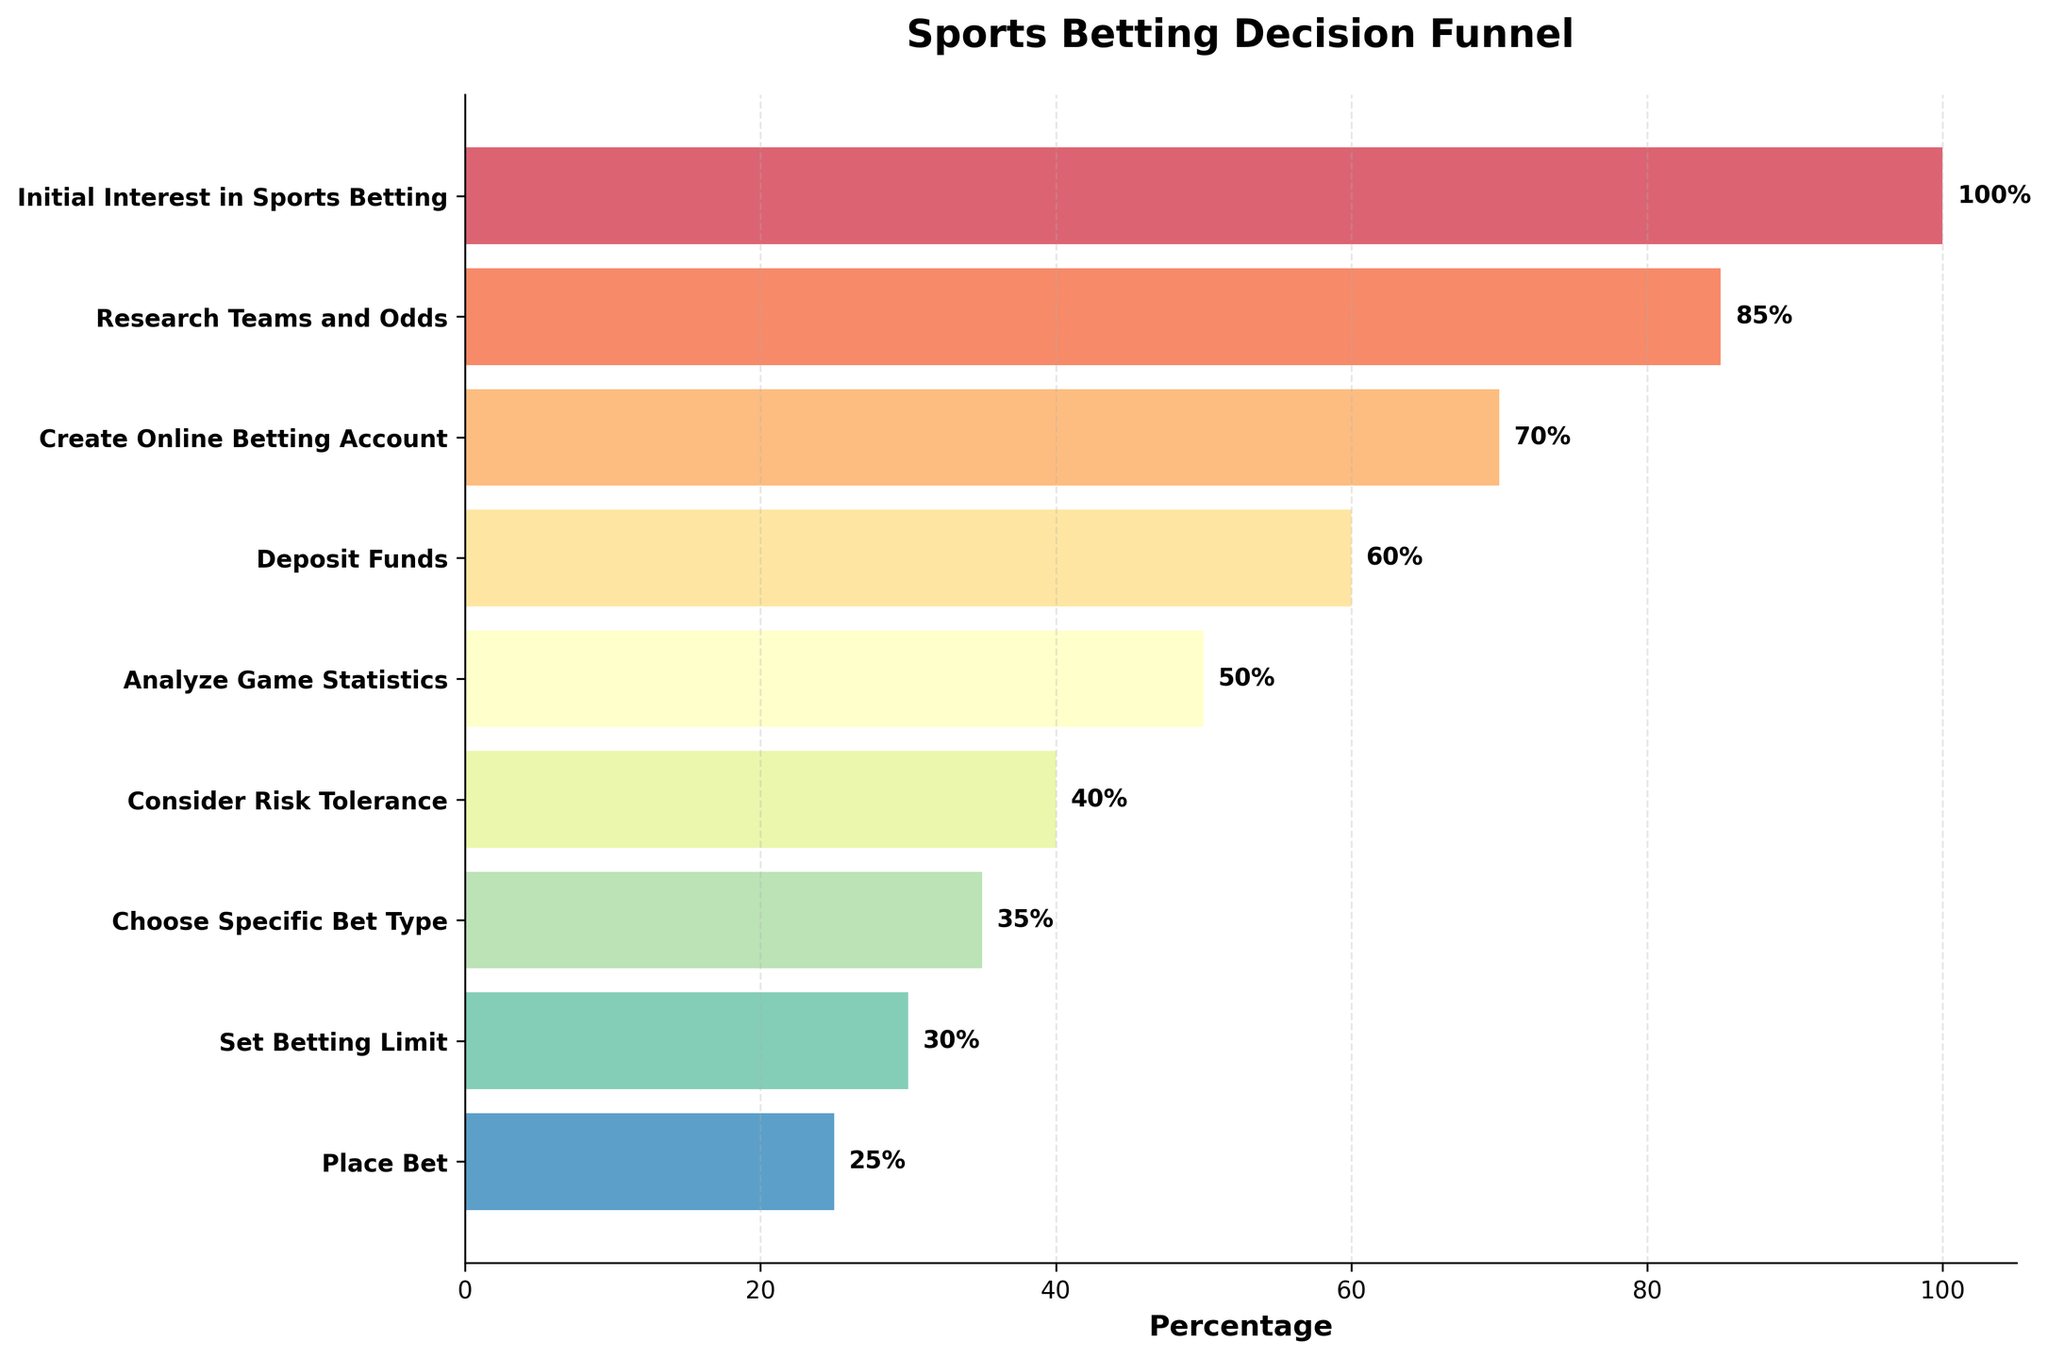What is the title of the funnel chart? The title of the chart is usually displayed at the top and it describes the subject of the visualization. In this case, the title is "Sports Betting Decision Funnel".
Answer: Sports Betting Decision Funnel What percentage of people reach the 'Deposit Funds' stage? The percentage for each stage is labeled on the horizontal bars. For 'Deposit Funds', the label next to the bar says 60%.
Answer: 60% Which stage sees the largest drop in percentage from the previous stage? To determine where the largest drop occurs, subtract the percentages of consecutive stages and find the maximum difference. The drop from 'Research Teams and Odds' (85%) to 'Create Online Betting Account' (70%) is 15%, which is the largest drop.
Answer: Research Teams and Odds to Create Online Betting Account What is the cumulative percentage drop from 'Initial Interest in Sports Betting' to 'Place Bet'? Add up the percentage drops from each stage to the next. The drops are:
- 100% to 85%: 15%
- 85% to 70%: 15%
- 70% to 60%: 10%
- 60% to 50%: 10%
- 50% to 40%: 10%
- 40% to 35%: 5%
- 35% to 30%: 5%
- 30% to 25%: 5%
Sum these up: 15 + 15 + 10 + 10 + 10 + 5 + 5 + 5 = 75%.
Answer: 75% At which stage do less than half of the initial individuals remain? Locate the stage where the percentage drops below 50%. The 'Analyze Game Statistics' stage has 50%, and 'Consider Risk Tolerance' has 40%, so 'Consider Risk Tolerance' is the stage where less than half remain.
Answer: Consider Risk Tolerance Which stage directly follows 'Analyze Game Statistics'? The stages are listed in order down the y-axis. 'Consider Risk Tolerance' comes directly after 'Analyze Game Statistics'.
Answer: Consider Risk Tolerance What percentage of people create an online betting account? The percentage for 'Create Online Betting Account' is indicated on the chart and is 70%.
Answer: 70% How many stages are in the sports betting decision funnel? Count the number of different stages listed on the y-axis. There are 9 stages from 'Initial Interest in Sports Betting' to 'Place Bet'.
Answer: 9 